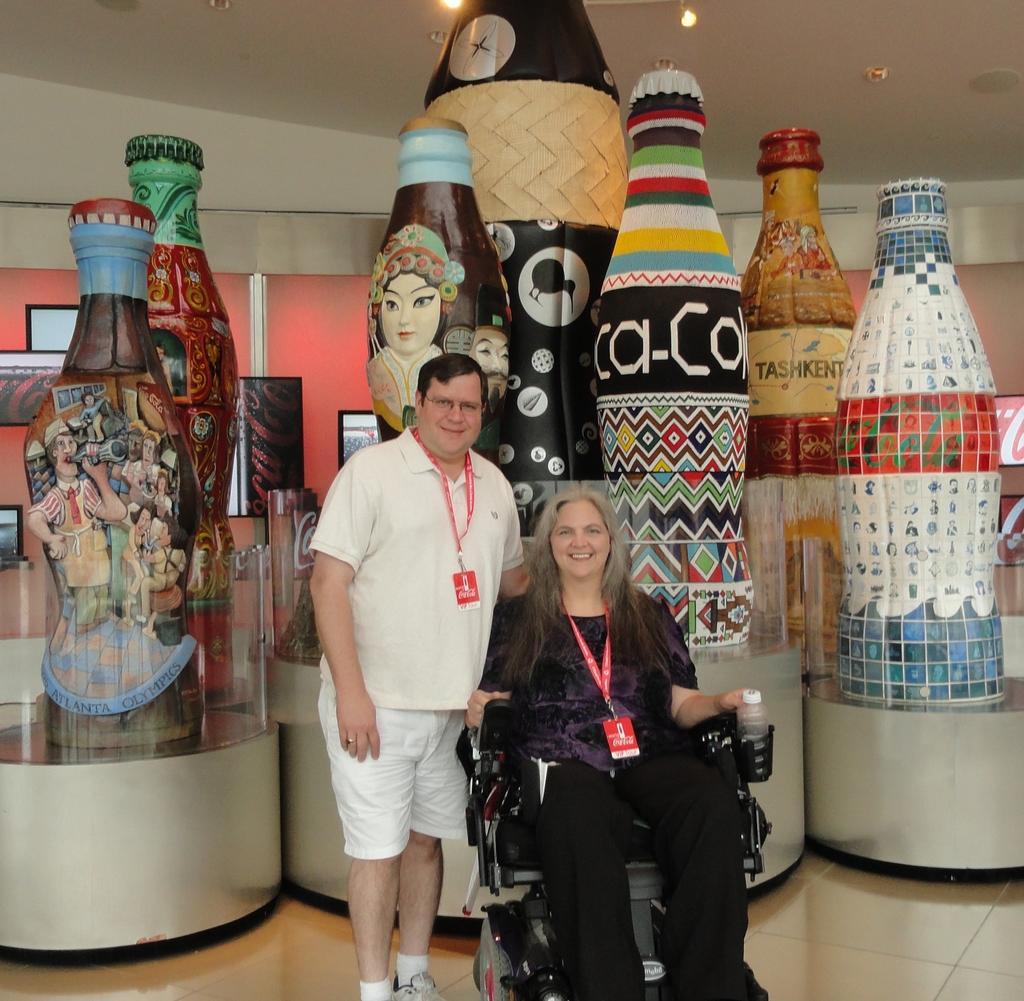Please provide a concise description of this image. In this picture we can see two people behind them there are some bottles. 